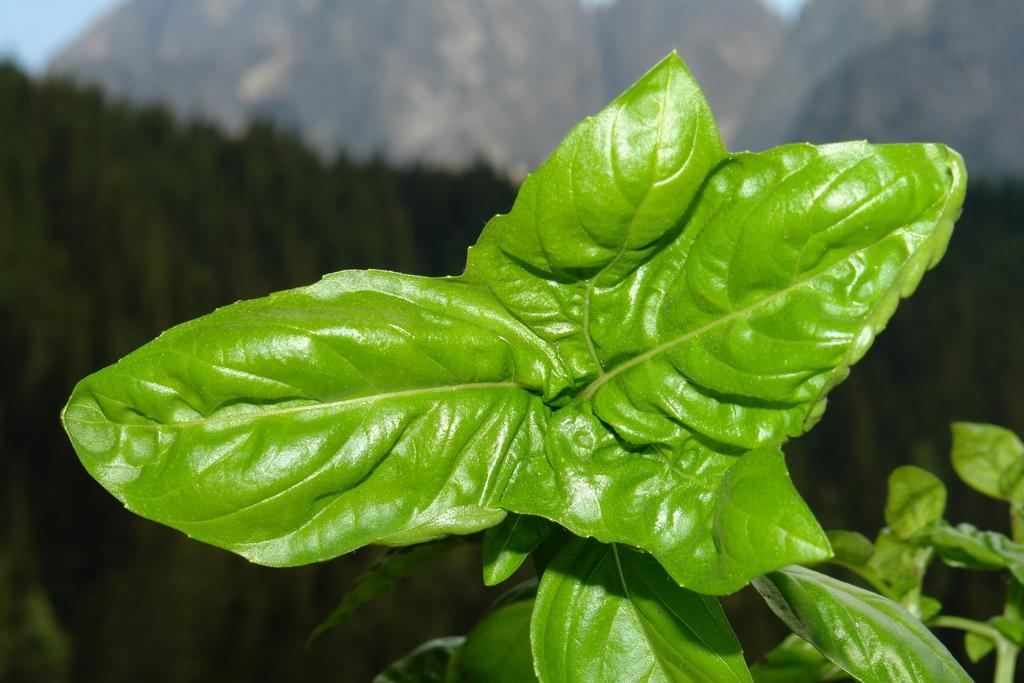How would you summarize this image in a sentence or two? In the center of the image there are leaves. In the background there are trees, hills and sky. 